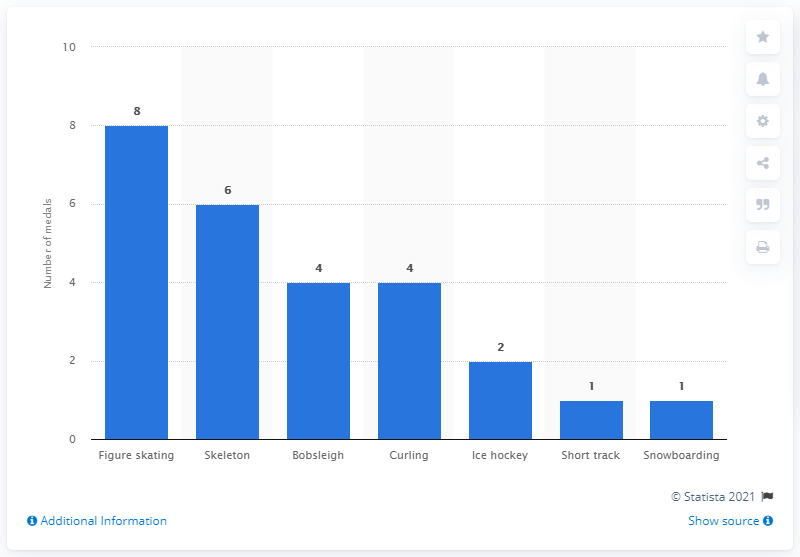Indicate a few pertinent items in this graphic. Skeleton had the most medals out of all the sports, according to the data. 